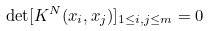Convert formula to latex. <formula><loc_0><loc_0><loc_500><loc_500>\det [ K ^ { N } ( x _ { i } , x _ { j } ) ] _ { 1 \leq i , j \leq m } = 0</formula> 